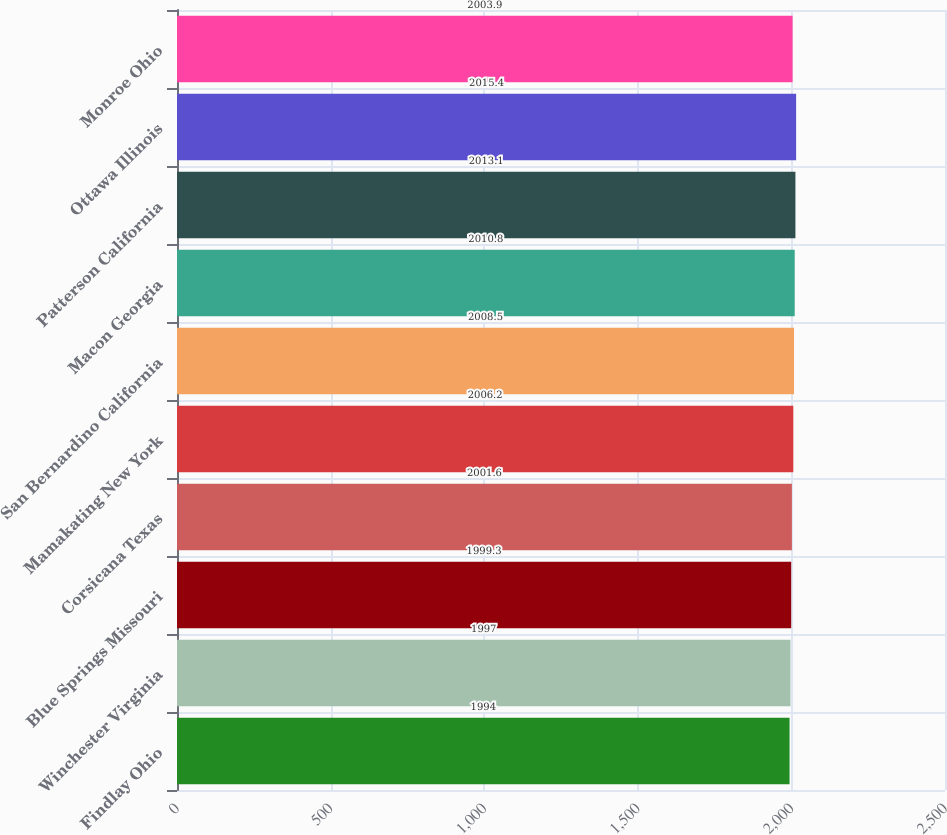Convert chart. <chart><loc_0><loc_0><loc_500><loc_500><bar_chart><fcel>Findlay Ohio<fcel>Winchester Virginia<fcel>Blue Springs Missouri<fcel>Corsicana Texas<fcel>Mamakating New York<fcel>San Bernardino California<fcel>Macon Georgia<fcel>Patterson California<fcel>Ottawa Illinois<fcel>Monroe Ohio<nl><fcel>1994<fcel>1997<fcel>1999.3<fcel>2001.6<fcel>2006.2<fcel>2008.5<fcel>2010.8<fcel>2013.1<fcel>2015.4<fcel>2003.9<nl></chart> 